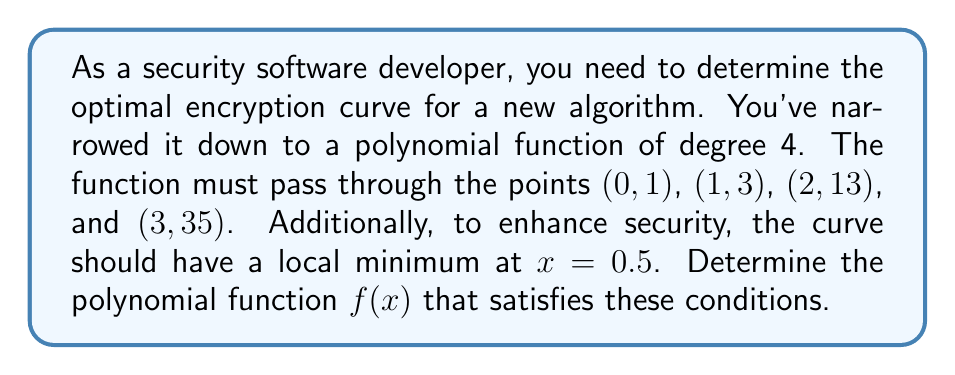Teach me how to tackle this problem. Let's approach this step-by-step:

1) We're looking for a polynomial of degree 4, so it will have the general form:
   $$f(x) = ax^4 + bx^3 + cx^2 + dx + e$$

2) We have 5 conditions to satisfy:
   a) $f(0) = 1$
   b) $f(1) = 3$
   c) $f(2) = 13$
   d) $f(3) = 35$
   e) $f'(0.5) = 0$ (local minimum at x = 0.5)

3) From condition a): $f(0) = e = 1$

4) Now we have:
   $$f(x) = ax^4 + bx^3 + cx^2 + dx + 1$$

5) Using the other point conditions:
   b) $a + b + c + d = 2$
   c) $16a + 8b + 4c + 2d = 12$
   d) $81a + 27b + 9c + 3d = 34$

6) For the local minimum condition:
   $$f'(x) = 4ax^3 + 3bx^2 + 2cx + d$$
   $$f'(0.5) = 4a(0.5)^3 + 3b(0.5)^2 + 2c(0.5) + d = 0$$
   $$0.5a + 0.75b + c + d = 0$$

7) We now have a system of 4 equations with 4 unknowns. Solving this system (using a computer algebra system or matrix methods) gives:
   $a = 1$, $b = -2$, $c = 5$, $d = -2$

8) Therefore, our polynomial function is:
   $$f(x) = x^4 - 2x^3 + 5x^2 - 2x + 1$$

9) We can verify that this function satisfies all the given conditions.
Answer: $$f(x) = x^4 - 2x^3 + 5x^2 - 2x + 1$$ 